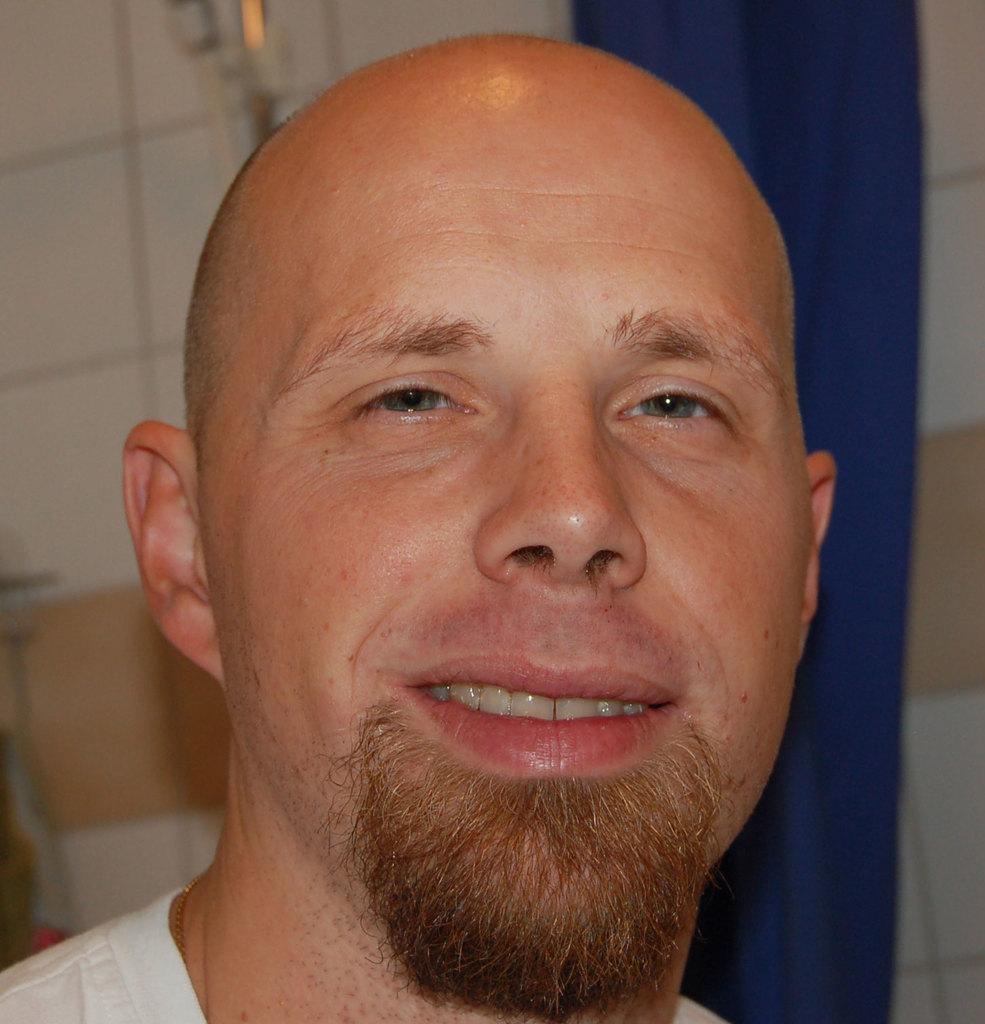Who or what is present in the image? There is a person in the image. What can be seen in the background of the image? There is a wall in the background of the image. Are there any additional features on the wall in the background? Yes, there are objects attached to the wall in the background. What type of tree can be seen in the image? There is no tree present in the image; it only features a person, a wall, and objects attached to the wall. Is there any smoke visible in the image? There is no smoke present in the image. 